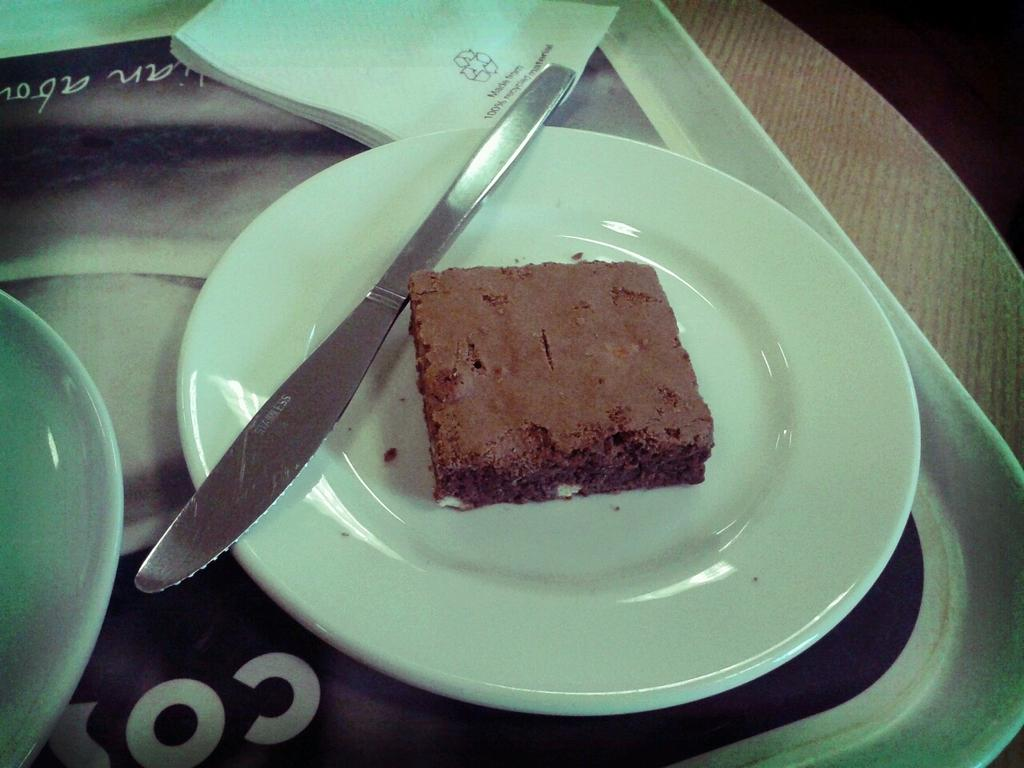What object is used to hold multiple items in the image? There is a tray in the image that holds multiple items. How many plates are on the tray? There are two plates on the tray. What utensil is present on the tray? There is a knife on the tray. What can be used for wiping or drying in the image? There are tissues on the tray for wiping or drying. What type of food is on one of the plates? There is a cake on one of the plates. Where is the tray located in the image? The tray is placed on a table. Where is the sister sitting in the image? There is no sister present in the image. What type of plants can be seen on the table in the image? There are no plants visible on the table in the image. 